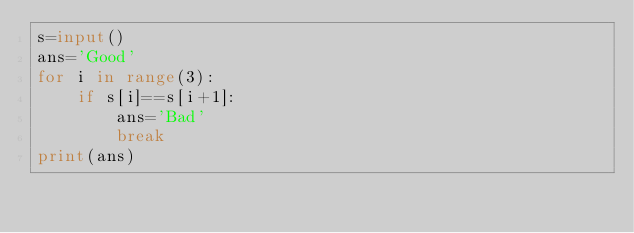Convert code to text. <code><loc_0><loc_0><loc_500><loc_500><_Python_>s=input()
ans='Good'
for i in range(3):
    if s[i]==s[i+1]:
        ans='Bad'
        break
print(ans)</code> 